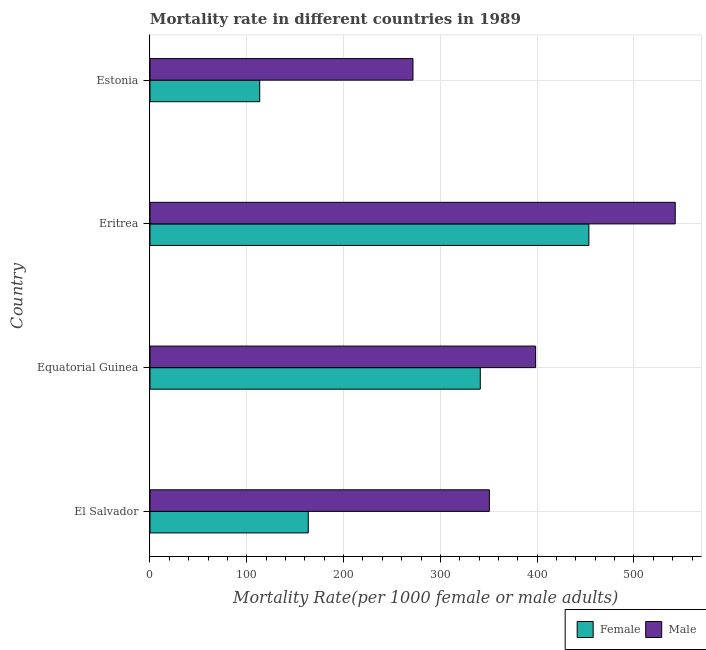How many groups of bars are there?
Provide a succinct answer. 4. Are the number of bars per tick equal to the number of legend labels?
Keep it short and to the point. Yes. How many bars are there on the 3rd tick from the bottom?
Offer a very short reply. 2. What is the label of the 3rd group of bars from the top?
Your response must be concise. Equatorial Guinea. In how many cases, is the number of bars for a given country not equal to the number of legend labels?
Offer a very short reply. 0. What is the male mortality rate in Equatorial Guinea?
Keep it short and to the point. 398.39. Across all countries, what is the maximum male mortality rate?
Offer a very short reply. 542.63. Across all countries, what is the minimum male mortality rate?
Keep it short and to the point. 271.7. In which country was the male mortality rate maximum?
Your answer should be very brief. Eritrea. In which country was the male mortality rate minimum?
Offer a terse response. Estonia. What is the total female mortality rate in the graph?
Provide a succinct answer. 1071.49. What is the difference between the female mortality rate in Eritrea and that in Estonia?
Offer a very short reply. 340.05. What is the difference between the female mortality rate in Estonia and the male mortality rate in Equatorial Guinea?
Keep it short and to the point. -285.04. What is the average female mortality rate per country?
Provide a succinct answer. 267.87. What is the difference between the male mortality rate and female mortality rate in Equatorial Guinea?
Your response must be concise. 57.17. In how many countries, is the female mortality rate greater than 340 ?
Provide a short and direct response. 2. What is the ratio of the female mortality rate in Equatorial Guinea to that in Estonia?
Offer a very short reply. 3.01. Is the difference between the male mortality rate in El Salvador and Eritrea greater than the difference between the female mortality rate in El Salvador and Eritrea?
Provide a succinct answer. Yes. What is the difference between the highest and the second highest male mortality rate?
Keep it short and to the point. 144.24. What is the difference between the highest and the lowest female mortality rate?
Make the answer very short. 340.05. What does the 1st bar from the top in El Salvador represents?
Your answer should be compact. Male. What does the 2nd bar from the bottom in Eritrea represents?
Offer a terse response. Male. Are all the bars in the graph horizontal?
Give a very brief answer. Yes. How many countries are there in the graph?
Provide a succinct answer. 4. What is the difference between two consecutive major ticks on the X-axis?
Your response must be concise. 100. Are the values on the major ticks of X-axis written in scientific E-notation?
Keep it short and to the point. No. Does the graph contain any zero values?
Make the answer very short. No. Does the graph contain grids?
Make the answer very short. Yes. How many legend labels are there?
Offer a terse response. 2. What is the title of the graph?
Offer a terse response. Mortality rate in different countries in 1989. Does "Current US$" appear as one of the legend labels in the graph?
Give a very brief answer. No. What is the label or title of the X-axis?
Your answer should be compact. Mortality Rate(per 1000 female or male adults). What is the Mortality Rate(per 1000 female or male adults) in Female in El Salvador?
Provide a short and direct response. 163.5. What is the Mortality Rate(per 1000 female or male adults) of Male in El Salvador?
Keep it short and to the point. 350.6. What is the Mortality Rate(per 1000 female or male adults) in Female in Equatorial Guinea?
Your response must be concise. 341.23. What is the Mortality Rate(per 1000 female or male adults) of Male in Equatorial Guinea?
Your answer should be very brief. 398.39. What is the Mortality Rate(per 1000 female or male adults) of Female in Eritrea?
Provide a short and direct response. 453.41. What is the Mortality Rate(per 1000 female or male adults) of Male in Eritrea?
Provide a short and direct response. 542.63. What is the Mortality Rate(per 1000 female or male adults) in Female in Estonia?
Provide a short and direct response. 113.36. What is the Mortality Rate(per 1000 female or male adults) in Male in Estonia?
Make the answer very short. 271.7. Across all countries, what is the maximum Mortality Rate(per 1000 female or male adults) in Female?
Provide a short and direct response. 453.41. Across all countries, what is the maximum Mortality Rate(per 1000 female or male adults) of Male?
Your answer should be compact. 542.63. Across all countries, what is the minimum Mortality Rate(per 1000 female or male adults) of Female?
Ensure brevity in your answer.  113.36. Across all countries, what is the minimum Mortality Rate(per 1000 female or male adults) in Male?
Your answer should be compact. 271.7. What is the total Mortality Rate(per 1000 female or male adults) in Female in the graph?
Provide a short and direct response. 1071.49. What is the total Mortality Rate(per 1000 female or male adults) of Male in the graph?
Keep it short and to the point. 1563.33. What is the difference between the Mortality Rate(per 1000 female or male adults) in Female in El Salvador and that in Equatorial Guinea?
Make the answer very short. -177.72. What is the difference between the Mortality Rate(per 1000 female or male adults) of Male in El Salvador and that in Equatorial Guinea?
Offer a terse response. -47.79. What is the difference between the Mortality Rate(per 1000 female or male adults) of Female in El Salvador and that in Eritrea?
Your answer should be compact. -289.91. What is the difference between the Mortality Rate(per 1000 female or male adults) in Male in El Salvador and that in Eritrea?
Your answer should be compact. -192.03. What is the difference between the Mortality Rate(per 1000 female or male adults) of Female in El Salvador and that in Estonia?
Keep it short and to the point. 50.15. What is the difference between the Mortality Rate(per 1000 female or male adults) in Male in El Salvador and that in Estonia?
Your answer should be very brief. 78.9. What is the difference between the Mortality Rate(per 1000 female or male adults) in Female in Equatorial Guinea and that in Eritrea?
Ensure brevity in your answer.  -112.19. What is the difference between the Mortality Rate(per 1000 female or male adults) in Male in Equatorial Guinea and that in Eritrea?
Provide a short and direct response. -144.24. What is the difference between the Mortality Rate(per 1000 female or male adults) of Female in Equatorial Guinea and that in Estonia?
Offer a very short reply. 227.87. What is the difference between the Mortality Rate(per 1000 female or male adults) of Male in Equatorial Guinea and that in Estonia?
Ensure brevity in your answer.  126.7. What is the difference between the Mortality Rate(per 1000 female or male adults) of Female in Eritrea and that in Estonia?
Your answer should be compact. 340.05. What is the difference between the Mortality Rate(per 1000 female or male adults) in Male in Eritrea and that in Estonia?
Give a very brief answer. 270.93. What is the difference between the Mortality Rate(per 1000 female or male adults) of Female in El Salvador and the Mortality Rate(per 1000 female or male adults) of Male in Equatorial Guinea?
Ensure brevity in your answer.  -234.89. What is the difference between the Mortality Rate(per 1000 female or male adults) in Female in El Salvador and the Mortality Rate(per 1000 female or male adults) in Male in Eritrea?
Make the answer very short. -379.13. What is the difference between the Mortality Rate(per 1000 female or male adults) in Female in El Salvador and the Mortality Rate(per 1000 female or male adults) in Male in Estonia?
Your answer should be compact. -108.2. What is the difference between the Mortality Rate(per 1000 female or male adults) in Female in Equatorial Guinea and the Mortality Rate(per 1000 female or male adults) in Male in Eritrea?
Keep it short and to the point. -201.41. What is the difference between the Mortality Rate(per 1000 female or male adults) in Female in Equatorial Guinea and the Mortality Rate(per 1000 female or male adults) in Male in Estonia?
Provide a succinct answer. 69.53. What is the difference between the Mortality Rate(per 1000 female or male adults) of Female in Eritrea and the Mortality Rate(per 1000 female or male adults) of Male in Estonia?
Your answer should be compact. 181.71. What is the average Mortality Rate(per 1000 female or male adults) of Female per country?
Make the answer very short. 267.87. What is the average Mortality Rate(per 1000 female or male adults) of Male per country?
Your response must be concise. 390.83. What is the difference between the Mortality Rate(per 1000 female or male adults) in Female and Mortality Rate(per 1000 female or male adults) in Male in El Salvador?
Give a very brief answer. -187.1. What is the difference between the Mortality Rate(per 1000 female or male adults) of Female and Mortality Rate(per 1000 female or male adults) of Male in Equatorial Guinea?
Your answer should be very brief. -57.17. What is the difference between the Mortality Rate(per 1000 female or male adults) of Female and Mortality Rate(per 1000 female or male adults) of Male in Eritrea?
Offer a terse response. -89.22. What is the difference between the Mortality Rate(per 1000 female or male adults) in Female and Mortality Rate(per 1000 female or male adults) in Male in Estonia?
Your answer should be compact. -158.34. What is the ratio of the Mortality Rate(per 1000 female or male adults) in Female in El Salvador to that in Equatorial Guinea?
Make the answer very short. 0.48. What is the ratio of the Mortality Rate(per 1000 female or male adults) in Female in El Salvador to that in Eritrea?
Offer a very short reply. 0.36. What is the ratio of the Mortality Rate(per 1000 female or male adults) of Male in El Salvador to that in Eritrea?
Make the answer very short. 0.65. What is the ratio of the Mortality Rate(per 1000 female or male adults) of Female in El Salvador to that in Estonia?
Offer a terse response. 1.44. What is the ratio of the Mortality Rate(per 1000 female or male adults) in Male in El Salvador to that in Estonia?
Give a very brief answer. 1.29. What is the ratio of the Mortality Rate(per 1000 female or male adults) in Female in Equatorial Guinea to that in Eritrea?
Your answer should be compact. 0.75. What is the ratio of the Mortality Rate(per 1000 female or male adults) in Male in Equatorial Guinea to that in Eritrea?
Your answer should be compact. 0.73. What is the ratio of the Mortality Rate(per 1000 female or male adults) of Female in Equatorial Guinea to that in Estonia?
Your answer should be very brief. 3.01. What is the ratio of the Mortality Rate(per 1000 female or male adults) of Male in Equatorial Guinea to that in Estonia?
Provide a succinct answer. 1.47. What is the ratio of the Mortality Rate(per 1000 female or male adults) in Female in Eritrea to that in Estonia?
Provide a short and direct response. 4. What is the ratio of the Mortality Rate(per 1000 female or male adults) in Male in Eritrea to that in Estonia?
Make the answer very short. 2. What is the difference between the highest and the second highest Mortality Rate(per 1000 female or male adults) of Female?
Provide a short and direct response. 112.19. What is the difference between the highest and the second highest Mortality Rate(per 1000 female or male adults) in Male?
Provide a succinct answer. 144.24. What is the difference between the highest and the lowest Mortality Rate(per 1000 female or male adults) of Female?
Your response must be concise. 340.05. What is the difference between the highest and the lowest Mortality Rate(per 1000 female or male adults) in Male?
Give a very brief answer. 270.93. 